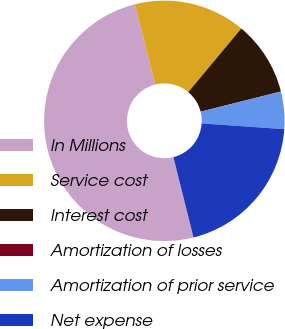<chart> <loc_0><loc_0><loc_500><loc_500><pie_chart><fcel>In Millions<fcel>Service cost<fcel>Interest cost<fcel>Amortization of losses<fcel>Amortization of prior service<fcel>Net expense<nl><fcel>49.97%<fcel>15.0%<fcel>10.01%<fcel>0.02%<fcel>5.01%<fcel>20.0%<nl></chart> 